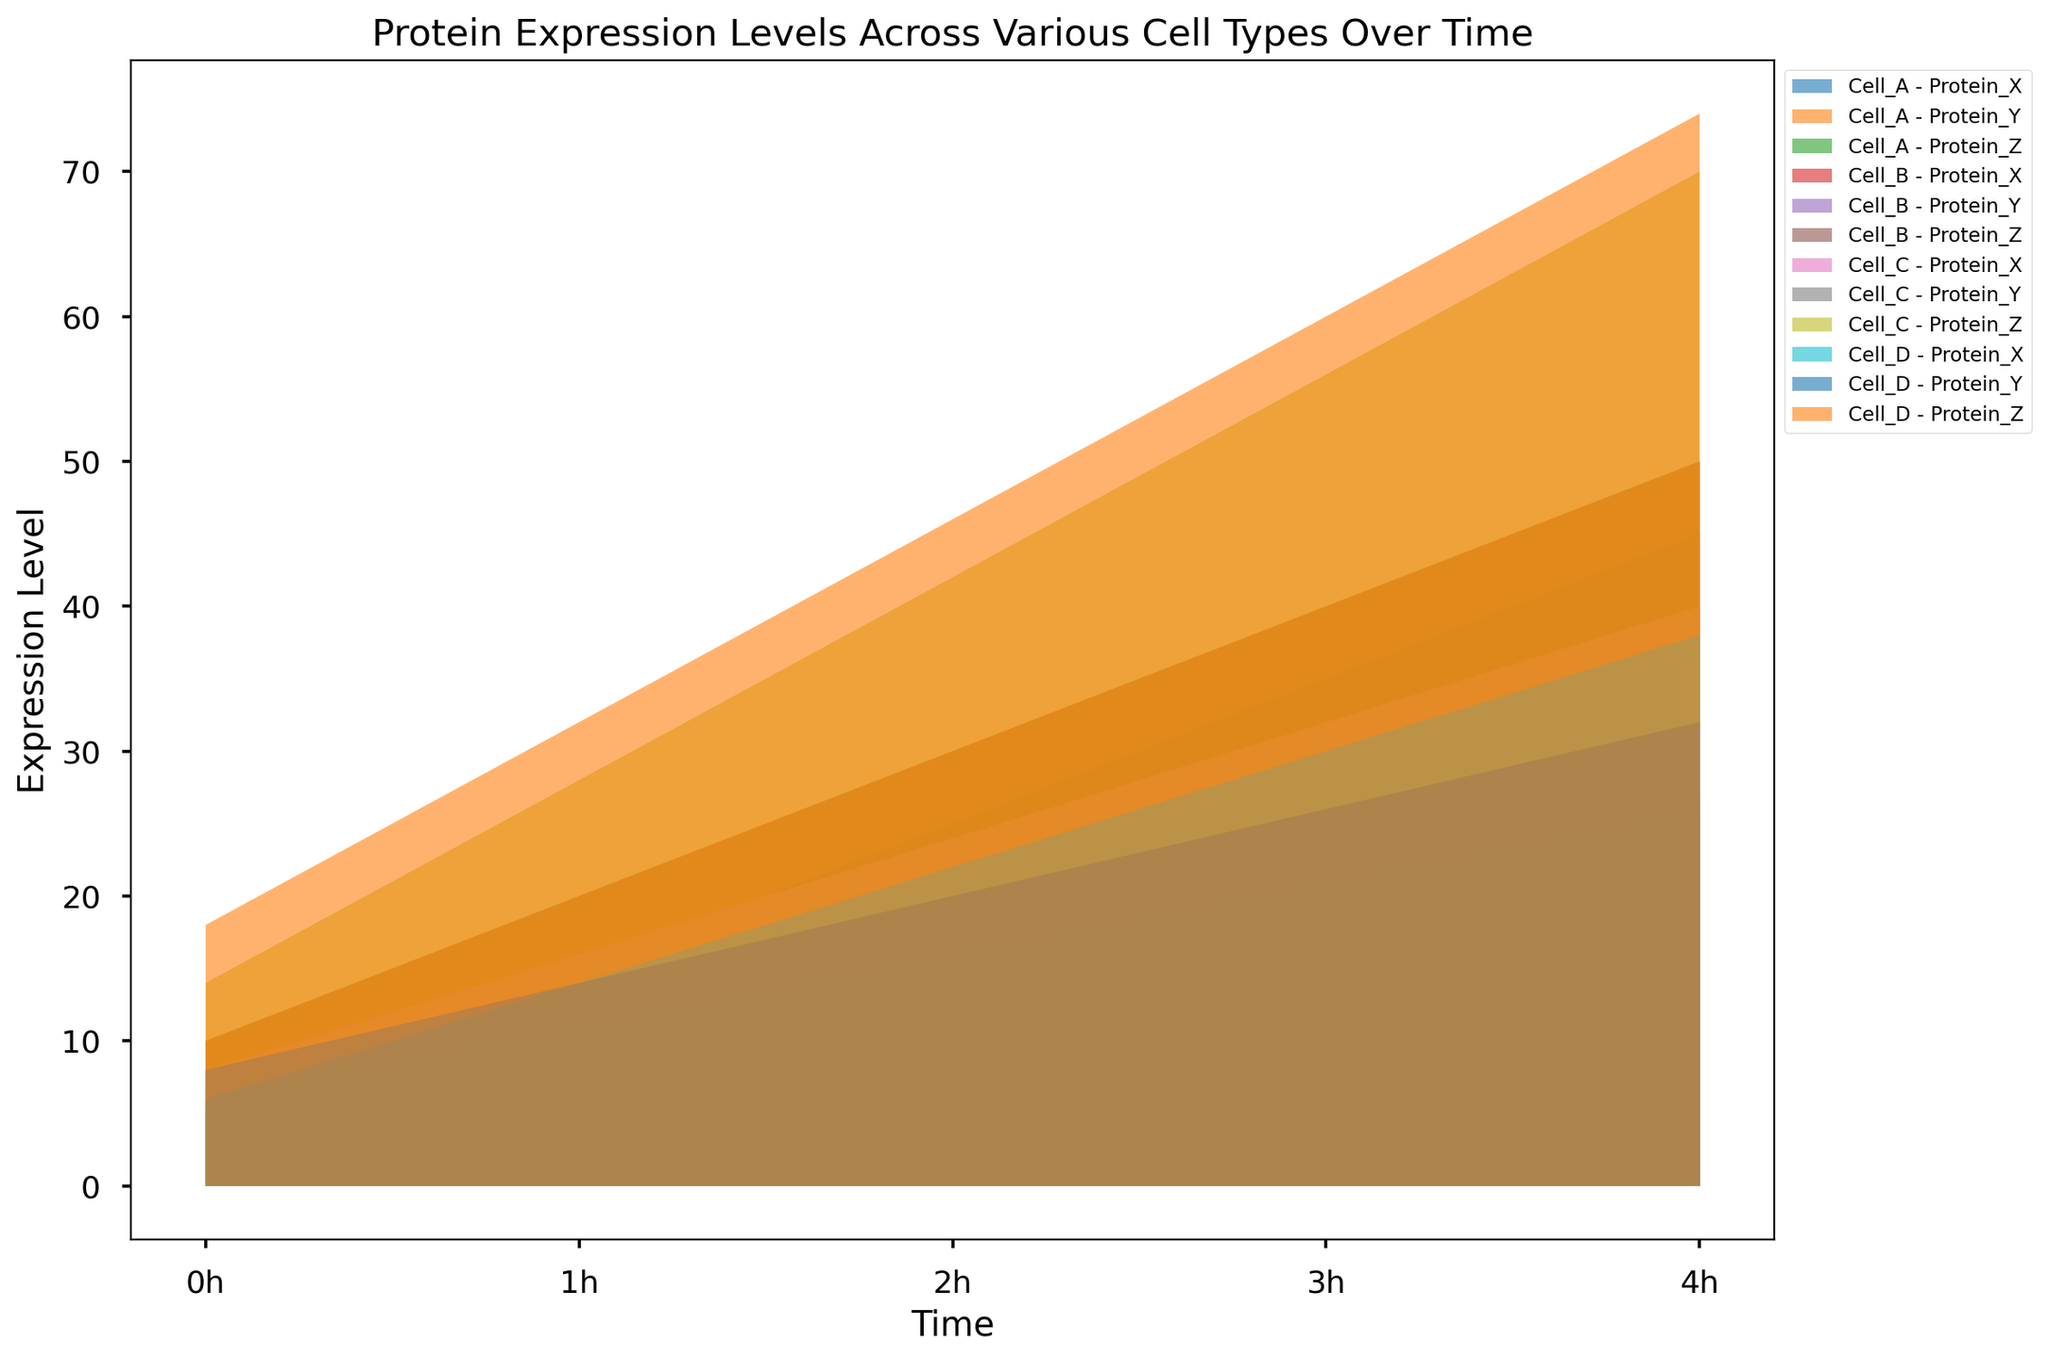Which cell type shows the highest expression level of Protein Z at 4h? To find the answer, look for the protein expression level of Protein Z for each cell type at 4h. By visually comparing the height of the areas, Cell_D has the highest expression level at 74.
Answer: Cell_D Which protein had the largest increase in expression from 0h to 4h in Cell_B? Calculate the difference in protein expression levels between 0h and 4h for each protein in Cell_B. Protein_X increased by 40 (50-10), Protein_Y by 20 (25-5), and Protein_Z by 32 (40-8). The largest increase is for Protein_X.
Answer: Protein_X Compare the expression levels of Protein Y in Cell_A and Cell_C at 2h. Which one is higher? Look at the expression levels of Protein_Y in both Cell_A and Cell_C at 2h. Protein_Y in Cell_A is 17, while Protein_Y in Cell_C is 16. Therefore, Cell_A has the higher expression level.
Answer: Cell_A Does any protein in Cell_D surpass the expression level of 30 before 4h? Check the expression levels of each protein in Cell_D at each time point before 4h. Protein_Z surpasses 30 at 3h with a level of 60.
Answer: Yes What is the total expression level of all proteins in Cell_A at 3h? Sum the expression levels of Protein_X (35), Protein_Y (22), and Protein_Z (40) in Cell_A at 3h. The total is 35 + 22 + 40 = 97.
Answer: 97 For Protein_X, which cell type shows the most consistent increase over the time course? Analyze the trend of Protein_X for each cell type. Cell_A shows a consistent linear increase (5, 15, 25, 35, 45) over time. The increases are the same between each time point.
Answer: Cell_A What is the average expression level of Protein_Y across all cell types at 4h? Sum the expression levels of Protein_Y for all cell types at 4h (27 + 25 + 26 + 32) and divide by 4. The average is (27 + 25 + 26 + 32) / 4 = 110 / 4 = 27.5.
Answer: 27.5 At which time point do Cell_A and Cell_B have the same expression level for Protein_Z? Compare the expression levels of Protein_Z in Cell_A and Cell_B at each time point. They have the same expression level of 40 at 3h.
Answer: 3h Which protein in Cell_C exhibited the highest rate of increase in expression from 0h to 4h? Calculate the rate of increase for each protein in Cell_C from 0h to 4h. Protein_X increased by 32 (40-8), Protein_Y by 20 (26-6), and Protein_Z by 56 (70-14). The highest rate is for Protein_Z.
Answer: Protein_Z How does the expression level of Protein_X in Cell_A at 1h compare to that in Cell_D at the same time point? Look at the expression levels of Protein_X in Cell_A (15) and Cell_D (14) at 1h. Protein_X in Cell_A is slightly higher by 1 unit.
Answer: Cell_A 